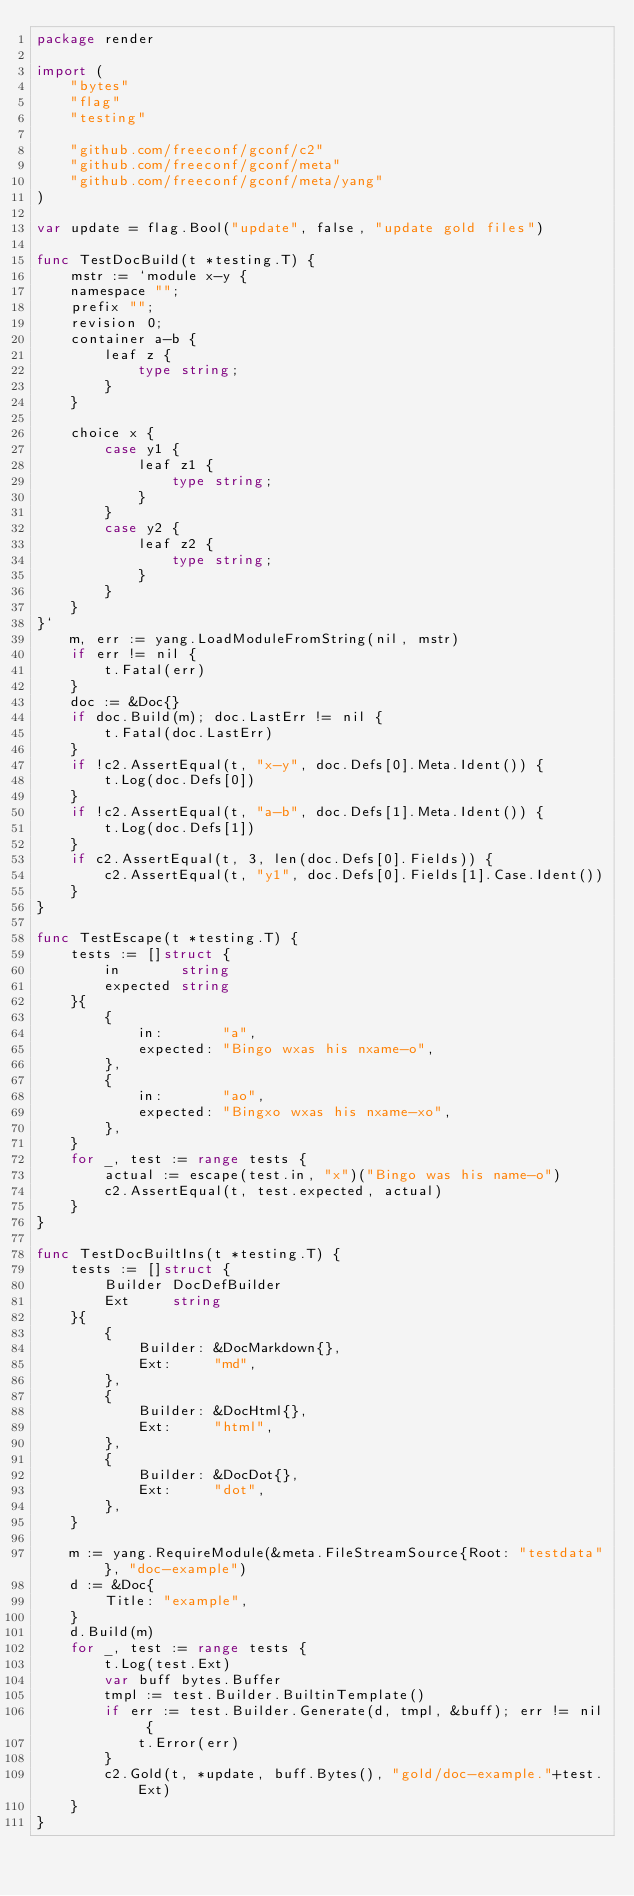<code> <loc_0><loc_0><loc_500><loc_500><_Go_>package render

import (
	"bytes"
	"flag"
	"testing"

	"github.com/freeconf/gconf/c2"
	"github.com/freeconf/gconf/meta"
	"github.com/freeconf/gconf/meta/yang"
)

var update = flag.Bool("update", false, "update gold files")

func TestDocBuild(t *testing.T) {
	mstr := `module x-y {
	namespace "";
	prefix "";
	revision 0;
	container a-b {
		leaf z {
			type string;
		}
	}

	choice x {
		case y1 {
			leaf z1 {
				type string;
			}
		}
		case y2 {
			leaf z2 {
				type string;
			}
		}
	}
}`
	m, err := yang.LoadModuleFromString(nil, mstr)
	if err != nil {
		t.Fatal(err)
	}
	doc := &Doc{}
	if doc.Build(m); doc.LastErr != nil {
		t.Fatal(doc.LastErr)
	}
	if !c2.AssertEqual(t, "x-y", doc.Defs[0].Meta.Ident()) {
		t.Log(doc.Defs[0])
	}
	if !c2.AssertEqual(t, "a-b", doc.Defs[1].Meta.Ident()) {
		t.Log(doc.Defs[1])
	}
	if c2.AssertEqual(t, 3, len(doc.Defs[0].Fields)) {
		c2.AssertEqual(t, "y1", doc.Defs[0].Fields[1].Case.Ident())
	}
}

func TestEscape(t *testing.T) {
	tests := []struct {
		in       string
		expected string
	}{
		{
			in:       "a",
			expected: "Bingo wxas his nxame-o",
		},
		{
			in:       "ao",
			expected: "Bingxo wxas his nxame-xo",
		},
	}
	for _, test := range tests {
		actual := escape(test.in, "x")("Bingo was his name-o")
		c2.AssertEqual(t, test.expected, actual)
	}
}

func TestDocBuiltIns(t *testing.T) {
	tests := []struct {
		Builder DocDefBuilder
		Ext     string
	}{
		{
			Builder: &DocMarkdown{},
			Ext:     "md",
		},
		{
			Builder: &DocHtml{},
			Ext:     "html",
		},
		{
			Builder: &DocDot{},
			Ext:     "dot",
		},
	}

	m := yang.RequireModule(&meta.FileStreamSource{Root: "testdata"}, "doc-example")
	d := &Doc{
		Title: "example",
	}
	d.Build(m)
	for _, test := range tests {
		t.Log(test.Ext)
		var buff bytes.Buffer
		tmpl := test.Builder.BuiltinTemplate()
		if err := test.Builder.Generate(d, tmpl, &buff); err != nil {
			t.Error(err)
		}
		c2.Gold(t, *update, buff.Bytes(), "gold/doc-example."+test.Ext)
	}
}
</code> 